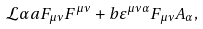<formula> <loc_0><loc_0><loc_500><loc_500>\mathcal { L } \alpha a F _ { \mu \nu } F ^ { \mu \nu } + b \varepsilon ^ { \mu \nu \alpha } F _ { \mu \nu } A _ { \alpha } ,</formula> 